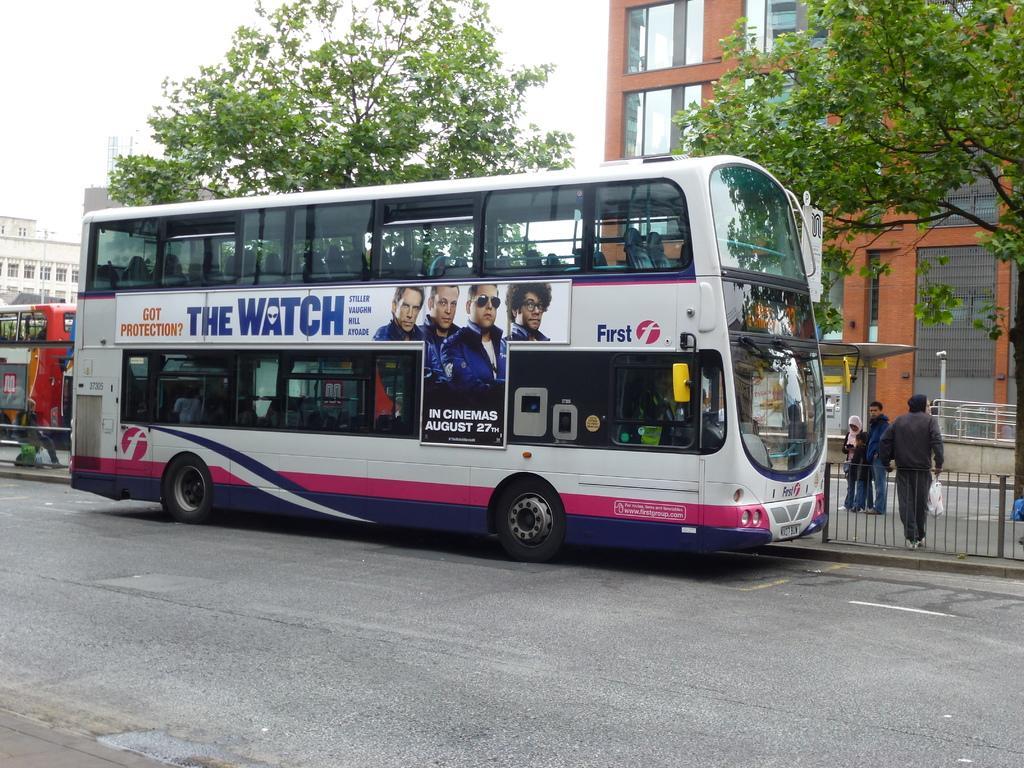Please provide a concise description of this image. In this image there are two Double Decker buses on the road, three persons standing, iron grills, buildings, trees, and in the background there is sky. 